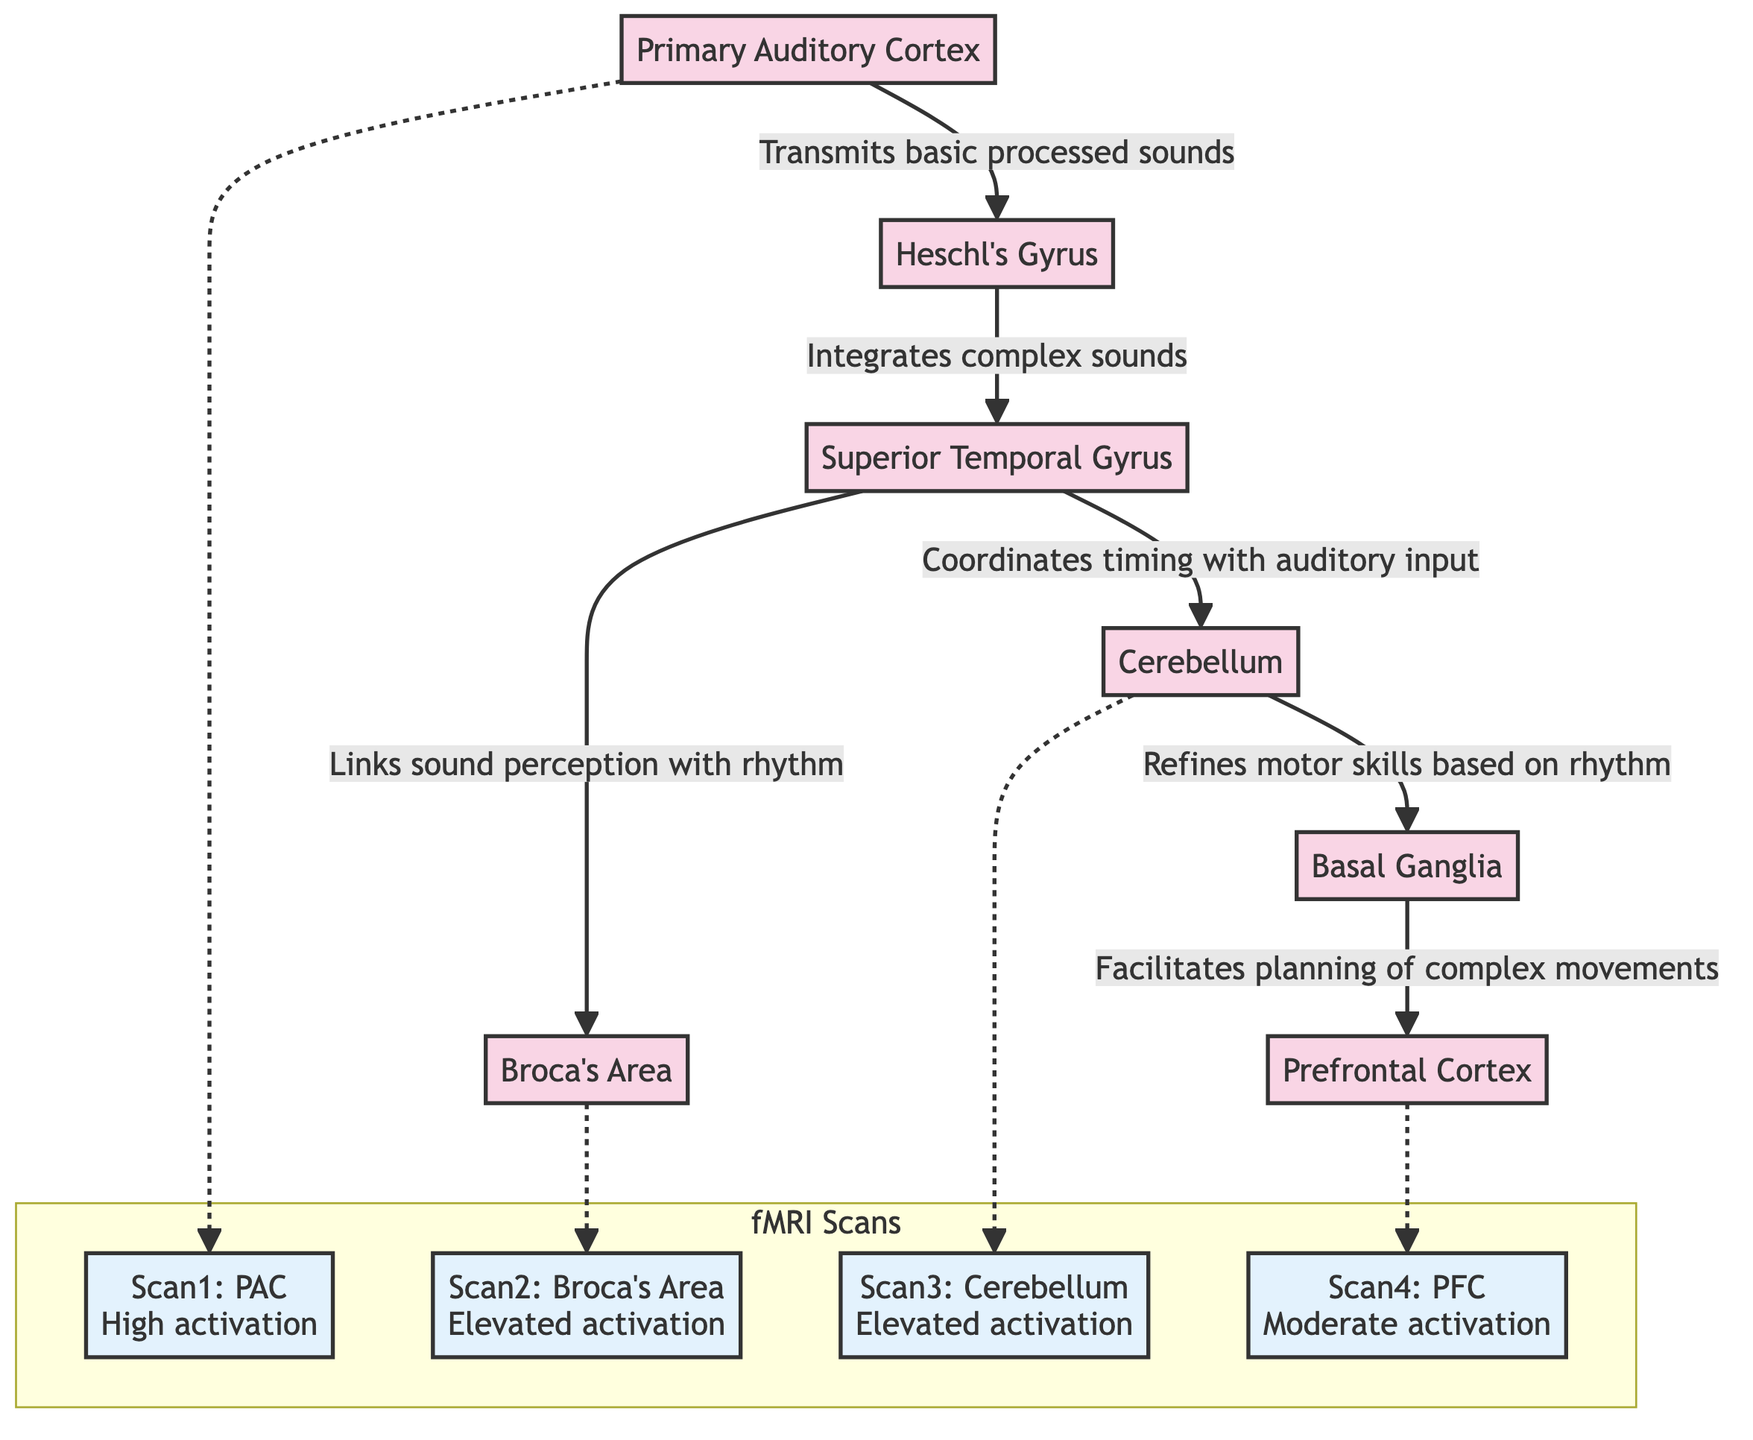What is the first node in the auditory pathway? The diagram shows the flow starting from PAC (Primary Auditory Cortex), marked as the first node that transmits processed sounds to the next node, Heschl's Gyrus.
Answer: PAC How many nodes are there in total within the diagram? By counting, we identify that there are seven distinct nodes: PAC, HG, STG, BA, C, BG, and PFC, making a total of seven.
Answer: 7 What does the STG link sound perception with? The diagram indicates that the Superior Temporal Gyrus (STG) links sound perception with rhythm, which is explicitly mentioned in the relationship leading to Broca’s Area.
Answer: Rhythm Which area is associated with motor skills refinement according to the diagram? The Cerebellum (C) is shown to refine motor skills based on rhythm, as indicated by the arrow leading to the Basal Ganglia (BG).
Answer: Cerebellum What type of activation is observed in Heschl's Gyrus according to fMRI scans? The fMRI scan indicates high activation in Heschl's Gyrus as noted in Scan 1, supporting its role in auditory processing.
Answer: High activation Which pathway facilitates the planning of complex movements? The Basal Ganglia (BG) is responsible for facilitating the planning of complex movements, as indicated by the connection leading to the Prefrontal Cortex (PFC).
Answer: Basal Ganglia How does the Primary Auditory Cortex relate to the fMRI scan results? The diagram shows that the PAC has a direct connection to fMRI Scan 1, indicating high activation, linking neural processing with auditory function.
Answer: Scan 1: PAC High activation What is the activation status in the Prefrontal Cortex mentioned in the diagram? The diagram states that the Prefrontal Cortex (PFC) has moderate activation, as specified in Scan 4, providing a context of its involvement in auditory processing.
Answer: Moderate activation 